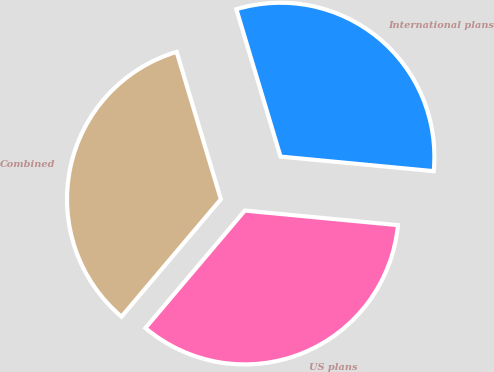Convert chart to OTSL. <chart><loc_0><loc_0><loc_500><loc_500><pie_chart><fcel>US plans<fcel>International plans<fcel>Combined<nl><fcel>34.67%<fcel>31.15%<fcel>34.19%<nl></chart> 